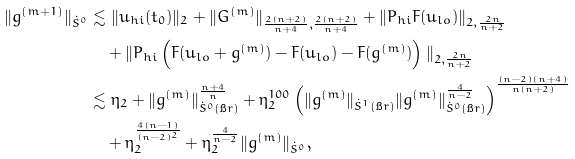Convert formula to latex. <formula><loc_0><loc_0><loc_500><loc_500>\| g ^ { ( m + 1 ) } \| _ { \dot { S } ^ { 0 } } & \lesssim \| u _ { h i } ( t _ { 0 } ) \| _ { 2 } + \| G ^ { ( m ) } \| _ { \frac { 2 ( n + 2 ) } { n + 4 } , \frac { 2 ( n + 2 ) } { n + 4 } } + \| P _ { h i } F ( u _ { l o } ) \| _ { 2 , \frac { 2 n } { n + 2 } } \\ & \quad + \| P _ { h i } \left ( F ( u _ { l o } + g ^ { ( m ) } ) - F ( u _ { l o } ) - F ( g ^ { ( m ) } ) \right ) \| _ { 2 , \frac { 2 n } { n + 2 } } \\ & \lesssim \eta _ { 2 } + \| g ^ { ( m ) } \| _ { \dot { S } ^ { 0 } ( \i r ) } ^ { \frac { n + 4 } { n } } + \eta _ { 2 } ^ { 1 0 0 } \left ( \| g ^ { ( m ) } \| _ { \dot { S } ^ { 1 } ( \i r ) } \| g ^ { ( m ) } \| _ { \dot { S } ^ { 0 } ( \i r ) } ^ { \frac { 4 } { n - 2 } } \right ) ^ { \frac { ( n - 2 ) ( n + 4 ) } { n ( n + 2 ) } } \\ & \quad + \eta _ { 2 } ^ { \frac { 4 ( n - 1 ) } { ( n - 2 ) ^ { 2 } } } + \eta _ { 2 } ^ { \frac { 4 } { n - 2 } } \| g ^ { ( m ) } \| _ { \dot { S } ^ { 0 } } ,</formula> 